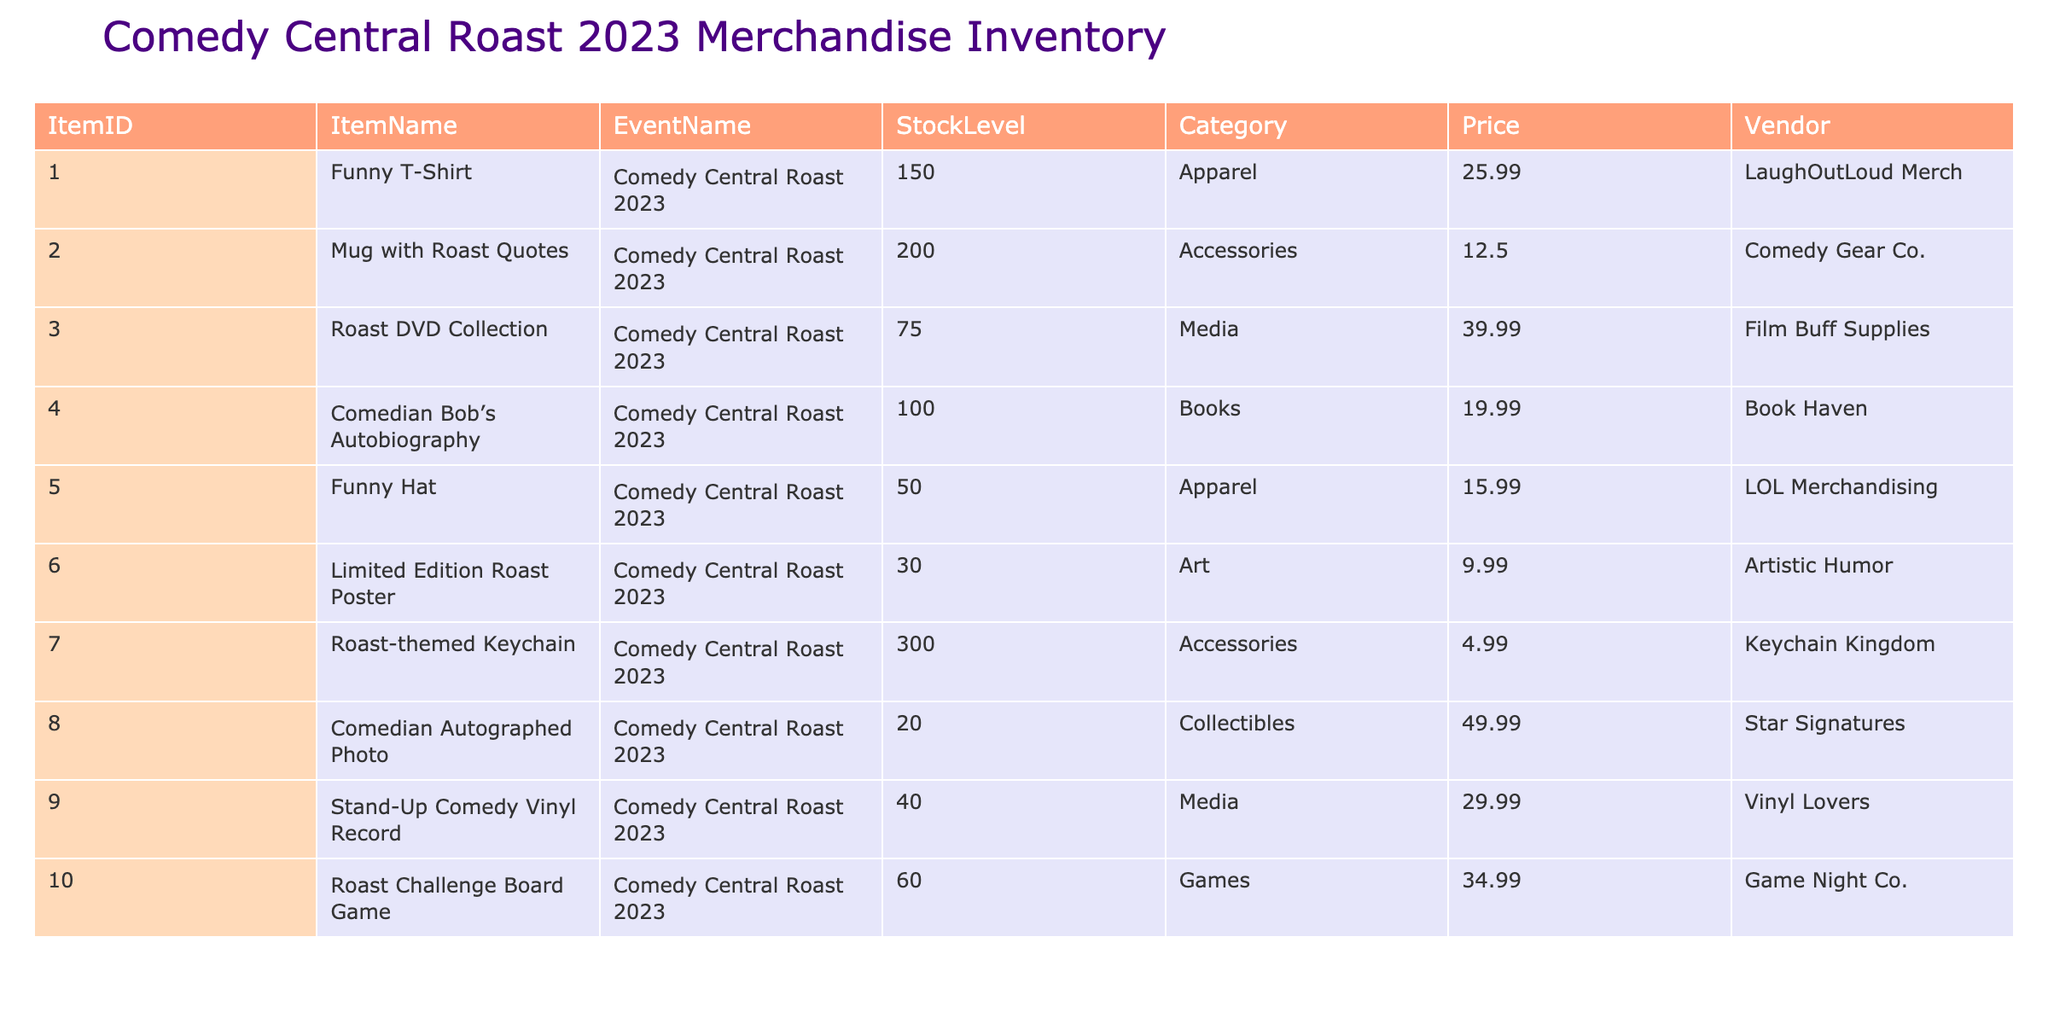What is the stock level of the "Funny T-Shirt"? The table shows the stock level for each item under the "StockLevel" column. For "Funny T-Shirt", the corresponding stock level is listed as 150.
Answer: 150 How many more "Mugs with Roast Quotes" are in stock compared to "Funny Hats"? The stock level for "Mugs with Roast Quotes" is 200 and for "Funny Hats" it is 50. The difference is 200 - 50 = 150.
Answer: 150 Is there a limited edition roast poster available? Yes, the table indicates that there are 30 "Limited Edition Roast Posters" in stock.
Answer: Yes What is the total stock level of all the accessories? The table lists two accessories: "Mug with Roast Quotes" with stock level 200 and "Roast-themed Keychain" with stock level 300. The total is 200 + 300 = 500.
Answer: 500 What is the average price of items categorized as "Media"? The items under "Media" are "Roast DVD Collection" priced at 39.99 and "Stand-Up Comedy Vinyl Record" priced at 29.99. The average price is (39.99 + 29.99) / 2 = 34.99.
Answer: 34.99 Are there any collectibles available in stock? Yes, the table lists "Comedian Autographed Photo" as a collectible item, with 20 units in stock.
Answer: Yes Which item has the highest stock level? By reviewing the "StockLevel" column, "Roast-themed Keychain" has the highest stock level of 300.
Answer: Roast-themed Keychain How much is the total value of all stock levels categorized as "Apparel"? The apparel items are "Funny T-Shirt" (150 units at 25.99), and "Funny Hat" (50 units at 15.99). The total value is (150 * 25.99) + (50 * 15.99) = 3898.5 + 799.5 = 4698.
Answer: 4698 What is the difference in price between the cheapest and the most expensive item? The cheapest item is the "Roast-themed Keychain" at 4.99 and the most expensive is the "Comedian Autographed Photo" at 49.99. The difference is 49.99 - 4.99 = 45.
Answer: 45 